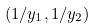<formula> <loc_0><loc_0><loc_500><loc_500>( 1 / y _ { 1 } , 1 / y _ { 2 } )</formula> 